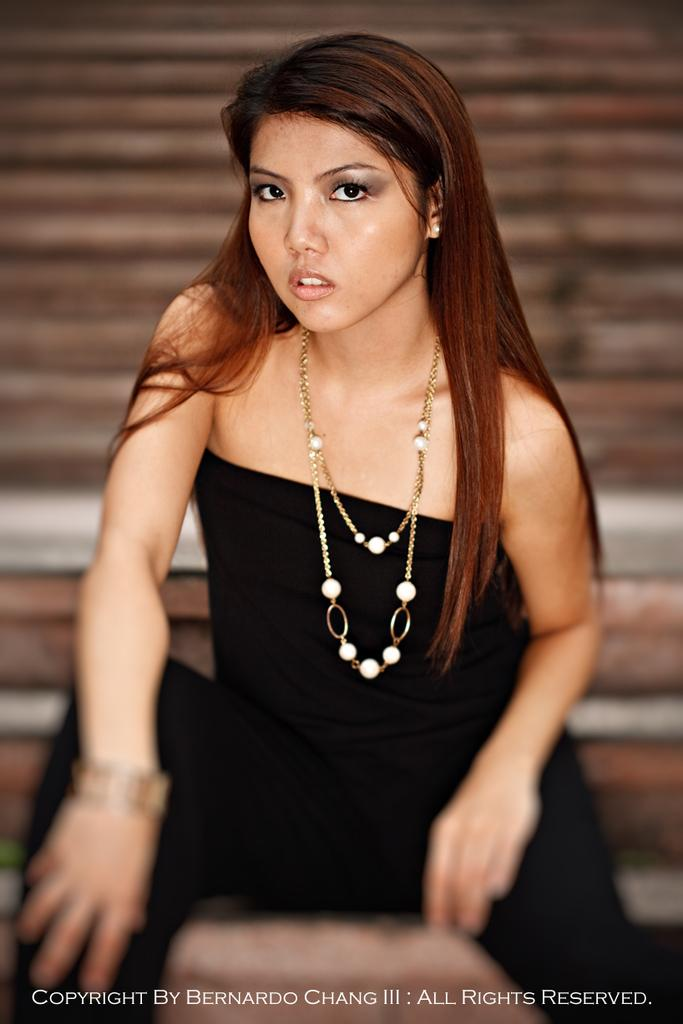Who is the main subject in the image? There is a woman in the image. What is the woman wearing? The woman is wearing a black dress and a necklace. Can you describe the quality of the image? The image is blurred in some areas. What type of wool is being spun in the image? There is no wool or spinning activity present in the image; it features a woman wearing a black dress and a necklace. 